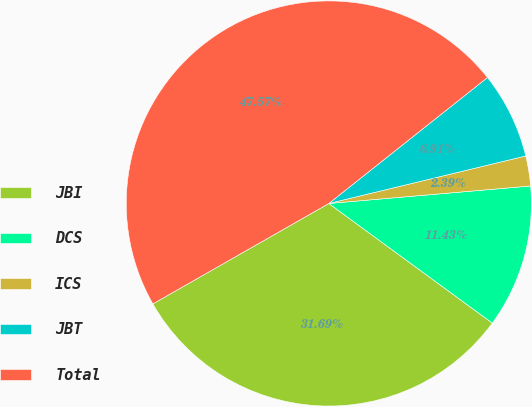<chart> <loc_0><loc_0><loc_500><loc_500><pie_chart><fcel>JBI<fcel>DCS<fcel>ICS<fcel>JBT<fcel>Total<nl><fcel>31.69%<fcel>11.43%<fcel>2.39%<fcel>6.91%<fcel>47.57%<nl></chart> 